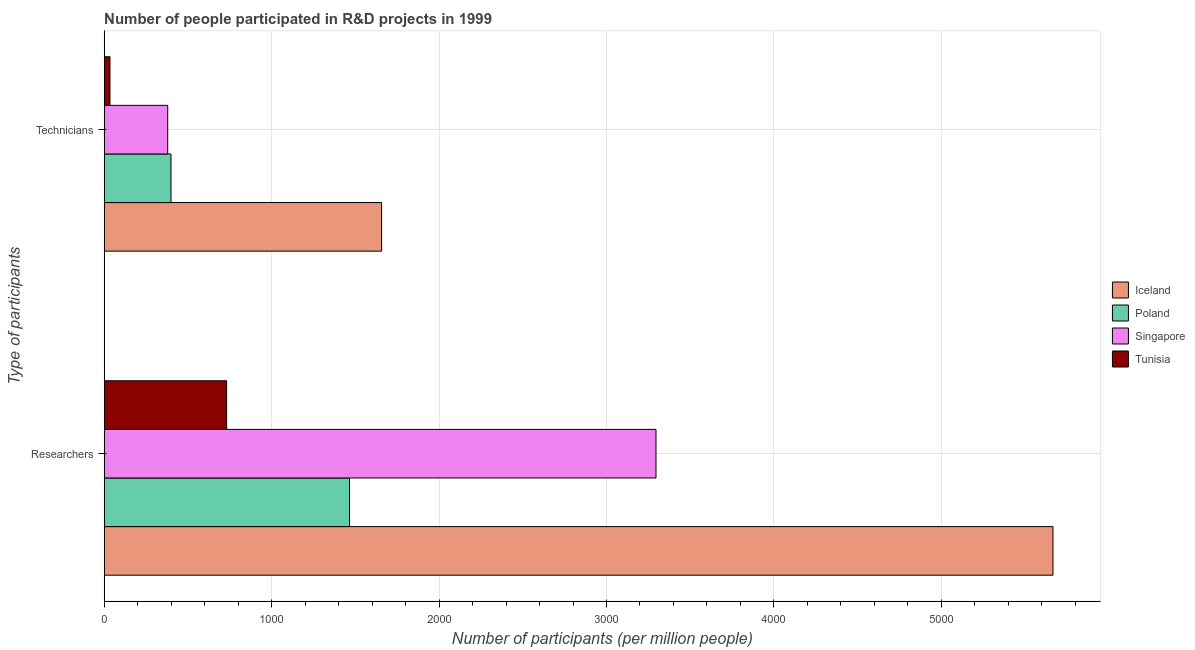How many different coloured bars are there?
Offer a terse response. 4. Are the number of bars per tick equal to the number of legend labels?
Provide a short and direct response. Yes. Are the number of bars on each tick of the Y-axis equal?
Keep it short and to the point. Yes. How many bars are there on the 2nd tick from the bottom?
Make the answer very short. 4. What is the label of the 1st group of bars from the top?
Offer a terse response. Technicians. What is the number of technicians in Iceland?
Your response must be concise. 1656.75. Across all countries, what is the maximum number of researchers?
Keep it short and to the point. 5666.8. Across all countries, what is the minimum number of researchers?
Give a very brief answer. 731.21. In which country was the number of technicians maximum?
Give a very brief answer. Iceland. In which country was the number of technicians minimum?
Make the answer very short. Tunisia. What is the total number of researchers in the graph?
Your response must be concise. 1.12e+04. What is the difference between the number of researchers in Tunisia and that in Poland?
Your answer should be very brief. -734. What is the difference between the number of researchers in Iceland and the number of technicians in Poland?
Ensure brevity in your answer.  5267.94. What is the average number of researchers per country?
Provide a short and direct response. 2789.74. What is the difference between the number of researchers and number of technicians in Poland?
Make the answer very short. 1066.35. In how many countries, is the number of researchers greater than 2800 ?
Provide a short and direct response. 2. What is the ratio of the number of researchers in Iceland to that in Singapore?
Offer a very short reply. 1.72. Is the number of technicians in Iceland less than that in Poland?
Offer a very short reply. No. In how many countries, is the number of researchers greater than the average number of researchers taken over all countries?
Give a very brief answer. 2. What does the 4th bar from the top in Researchers represents?
Offer a very short reply. Iceland. What does the 3rd bar from the bottom in Researchers represents?
Make the answer very short. Singapore. How many bars are there?
Provide a short and direct response. 8. How many countries are there in the graph?
Give a very brief answer. 4. What is the difference between two consecutive major ticks on the X-axis?
Provide a short and direct response. 1000. Are the values on the major ticks of X-axis written in scientific E-notation?
Your answer should be very brief. No. Does the graph contain any zero values?
Your answer should be compact. No. Does the graph contain grids?
Ensure brevity in your answer.  Yes. What is the title of the graph?
Give a very brief answer. Number of people participated in R&D projects in 1999. Does "Euro area" appear as one of the legend labels in the graph?
Your response must be concise. No. What is the label or title of the X-axis?
Offer a very short reply. Number of participants (per million people). What is the label or title of the Y-axis?
Provide a succinct answer. Type of participants. What is the Number of participants (per million people) of Iceland in Researchers?
Your response must be concise. 5666.8. What is the Number of participants (per million people) in Poland in Researchers?
Provide a succinct answer. 1465.21. What is the Number of participants (per million people) in Singapore in Researchers?
Make the answer very short. 3295.76. What is the Number of participants (per million people) of Tunisia in Researchers?
Keep it short and to the point. 731.21. What is the Number of participants (per million people) of Iceland in Technicians?
Provide a succinct answer. 1656.75. What is the Number of participants (per million people) in Poland in Technicians?
Your answer should be very brief. 398.85. What is the Number of participants (per million people) of Singapore in Technicians?
Give a very brief answer. 379.31. What is the Number of participants (per million people) in Tunisia in Technicians?
Provide a short and direct response. 34.49. Across all Type of participants, what is the maximum Number of participants (per million people) in Iceland?
Provide a succinct answer. 5666.8. Across all Type of participants, what is the maximum Number of participants (per million people) in Poland?
Your answer should be compact. 1465.21. Across all Type of participants, what is the maximum Number of participants (per million people) in Singapore?
Your answer should be compact. 3295.76. Across all Type of participants, what is the maximum Number of participants (per million people) of Tunisia?
Give a very brief answer. 731.21. Across all Type of participants, what is the minimum Number of participants (per million people) of Iceland?
Provide a succinct answer. 1656.75. Across all Type of participants, what is the minimum Number of participants (per million people) of Poland?
Keep it short and to the point. 398.85. Across all Type of participants, what is the minimum Number of participants (per million people) in Singapore?
Provide a succinct answer. 379.31. Across all Type of participants, what is the minimum Number of participants (per million people) of Tunisia?
Provide a short and direct response. 34.49. What is the total Number of participants (per million people) of Iceland in the graph?
Your answer should be very brief. 7323.55. What is the total Number of participants (per million people) of Poland in the graph?
Give a very brief answer. 1864.06. What is the total Number of participants (per million people) in Singapore in the graph?
Ensure brevity in your answer.  3675.06. What is the total Number of participants (per million people) in Tunisia in the graph?
Your answer should be very brief. 765.7. What is the difference between the Number of participants (per million people) of Iceland in Researchers and that in Technicians?
Give a very brief answer. 4010.04. What is the difference between the Number of participants (per million people) of Poland in Researchers and that in Technicians?
Your answer should be very brief. 1066.35. What is the difference between the Number of participants (per million people) of Singapore in Researchers and that in Technicians?
Provide a short and direct response. 2916.45. What is the difference between the Number of participants (per million people) of Tunisia in Researchers and that in Technicians?
Provide a succinct answer. 696.72. What is the difference between the Number of participants (per million people) in Iceland in Researchers and the Number of participants (per million people) in Poland in Technicians?
Offer a terse response. 5267.94. What is the difference between the Number of participants (per million people) in Iceland in Researchers and the Number of participants (per million people) in Singapore in Technicians?
Give a very brief answer. 5287.49. What is the difference between the Number of participants (per million people) in Iceland in Researchers and the Number of participants (per million people) in Tunisia in Technicians?
Your answer should be compact. 5632.3. What is the difference between the Number of participants (per million people) in Poland in Researchers and the Number of participants (per million people) in Singapore in Technicians?
Make the answer very short. 1085.9. What is the difference between the Number of participants (per million people) in Poland in Researchers and the Number of participants (per million people) in Tunisia in Technicians?
Offer a terse response. 1430.72. What is the difference between the Number of participants (per million people) of Singapore in Researchers and the Number of participants (per million people) of Tunisia in Technicians?
Provide a short and direct response. 3261.26. What is the average Number of participants (per million people) in Iceland per Type of participants?
Offer a terse response. 3661.77. What is the average Number of participants (per million people) in Poland per Type of participants?
Make the answer very short. 932.03. What is the average Number of participants (per million people) of Singapore per Type of participants?
Your response must be concise. 1837.53. What is the average Number of participants (per million people) in Tunisia per Type of participants?
Give a very brief answer. 382.85. What is the difference between the Number of participants (per million people) of Iceland and Number of participants (per million people) of Poland in Researchers?
Offer a very short reply. 4201.59. What is the difference between the Number of participants (per million people) in Iceland and Number of participants (per million people) in Singapore in Researchers?
Your answer should be compact. 2371.04. What is the difference between the Number of participants (per million people) of Iceland and Number of participants (per million people) of Tunisia in Researchers?
Provide a short and direct response. 4935.59. What is the difference between the Number of participants (per million people) in Poland and Number of participants (per million people) in Singapore in Researchers?
Your answer should be compact. -1830.55. What is the difference between the Number of participants (per million people) in Poland and Number of participants (per million people) in Tunisia in Researchers?
Provide a succinct answer. 734. What is the difference between the Number of participants (per million people) in Singapore and Number of participants (per million people) in Tunisia in Researchers?
Provide a succinct answer. 2564.55. What is the difference between the Number of participants (per million people) of Iceland and Number of participants (per million people) of Poland in Technicians?
Offer a very short reply. 1257.9. What is the difference between the Number of participants (per million people) in Iceland and Number of participants (per million people) in Singapore in Technicians?
Ensure brevity in your answer.  1277.44. What is the difference between the Number of participants (per million people) of Iceland and Number of participants (per million people) of Tunisia in Technicians?
Your answer should be compact. 1622.26. What is the difference between the Number of participants (per million people) of Poland and Number of participants (per million people) of Singapore in Technicians?
Make the answer very short. 19.55. What is the difference between the Number of participants (per million people) of Poland and Number of participants (per million people) of Tunisia in Technicians?
Your answer should be compact. 364.36. What is the difference between the Number of participants (per million people) of Singapore and Number of participants (per million people) of Tunisia in Technicians?
Your answer should be very brief. 344.82. What is the ratio of the Number of participants (per million people) in Iceland in Researchers to that in Technicians?
Offer a terse response. 3.42. What is the ratio of the Number of participants (per million people) of Poland in Researchers to that in Technicians?
Ensure brevity in your answer.  3.67. What is the ratio of the Number of participants (per million people) in Singapore in Researchers to that in Technicians?
Make the answer very short. 8.69. What is the ratio of the Number of participants (per million people) in Tunisia in Researchers to that in Technicians?
Provide a short and direct response. 21.2. What is the difference between the highest and the second highest Number of participants (per million people) of Iceland?
Offer a terse response. 4010.04. What is the difference between the highest and the second highest Number of participants (per million people) in Poland?
Provide a succinct answer. 1066.35. What is the difference between the highest and the second highest Number of participants (per million people) of Singapore?
Your answer should be very brief. 2916.45. What is the difference between the highest and the second highest Number of participants (per million people) of Tunisia?
Keep it short and to the point. 696.72. What is the difference between the highest and the lowest Number of participants (per million people) of Iceland?
Make the answer very short. 4010.04. What is the difference between the highest and the lowest Number of participants (per million people) in Poland?
Provide a short and direct response. 1066.35. What is the difference between the highest and the lowest Number of participants (per million people) in Singapore?
Offer a very short reply. 2916.45. What is the difference between the highest and the lowest Number of participants (per million people) of Tunisia?
Your response must be concise. 696.72. 